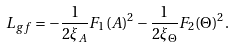<formula> <loc_0><loc_0><loc_500><loc_500>L _ { g f } = - \frac { 1 } { 2 \xi _ { A } } F _ { 1 } ( A ) ^ { 2 } - \frac { 1 } { 2 \xi _ { \Theta } } F _ { 2 } ( \Theta ) ^ { 2 } .</formula> 